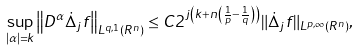Convert formula to latex. <formula><loc_0><loc_0><loc_500><loc_500>\sup _ { | \alpha | = k } \left \| D ^ { \alpha } \dot { \Delta } _ { j } f \right \| _ { L ^ { q , 1 } \left ( R ^ { n } \right ) } \leq C 2 ^ { j \left ( k + n \left ( \frac { 1 } { p } - \frac { 1 } { q } \right ) \right ) } \| \dot { \Delta } _ { j } f \| _ { L ^ { p , \infty } \left ( R ^ { n } \right ) } ,</formula> 